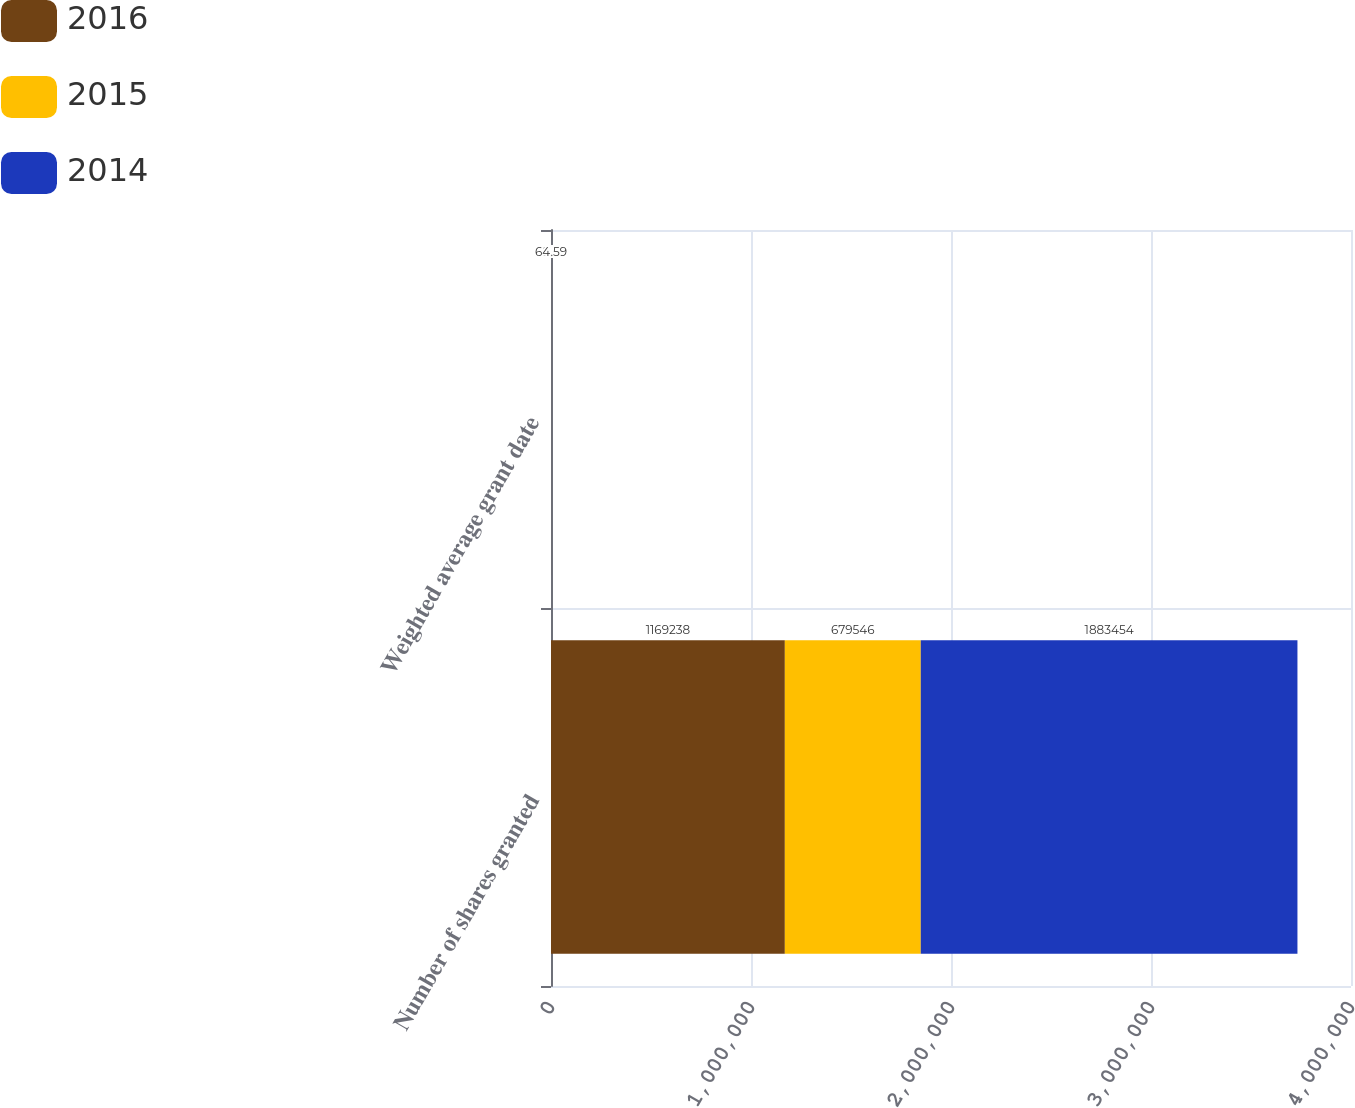Convert chart to OTSL. <chart><loc_0><loc_0><loc_500><loc_500><stacked_bar_chart><ecel><fcel>Number of shares granted<fcel>Weighted average grant date<nl><fcel>2016<fcel>1.16924e+06<fcel>59.73<nl><fcel>2015<fcel>679546<fcel>82.38<nl><fcel>2014<fcel>1.88345e+06<fcel>64.59<nl></chart> 